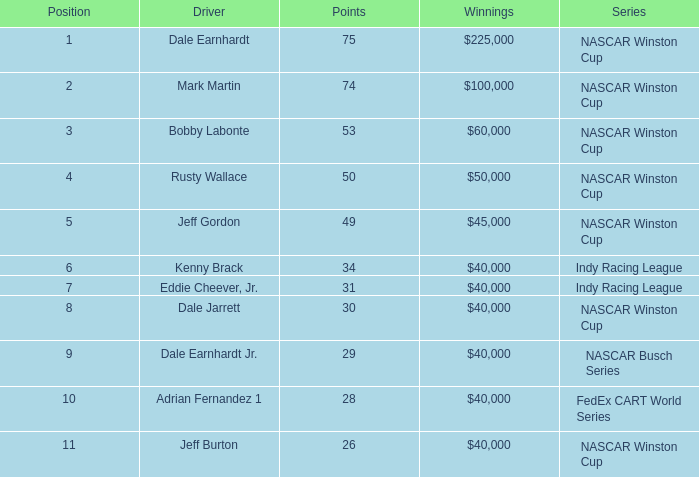In which sequence did bobby labonte participate? NASCAR Winston Cup. 